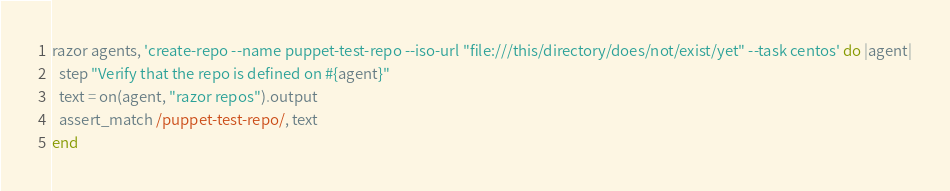Convert code to text. <code><loc_0><loc_0><loc_500><loc_500><_Ruby_>razor agents, 'create-repo --name puppet-test-repo --iso-url "file:///this/directory/does/not/exist/yet" --task centos' do |agent|
  step "Verify that the repo is defined on #{agent}"
  text = on(agent, "razor repos").output
  assert_match /puppet-test-repo/, text
end</code> 